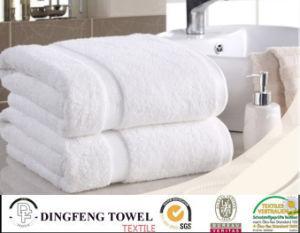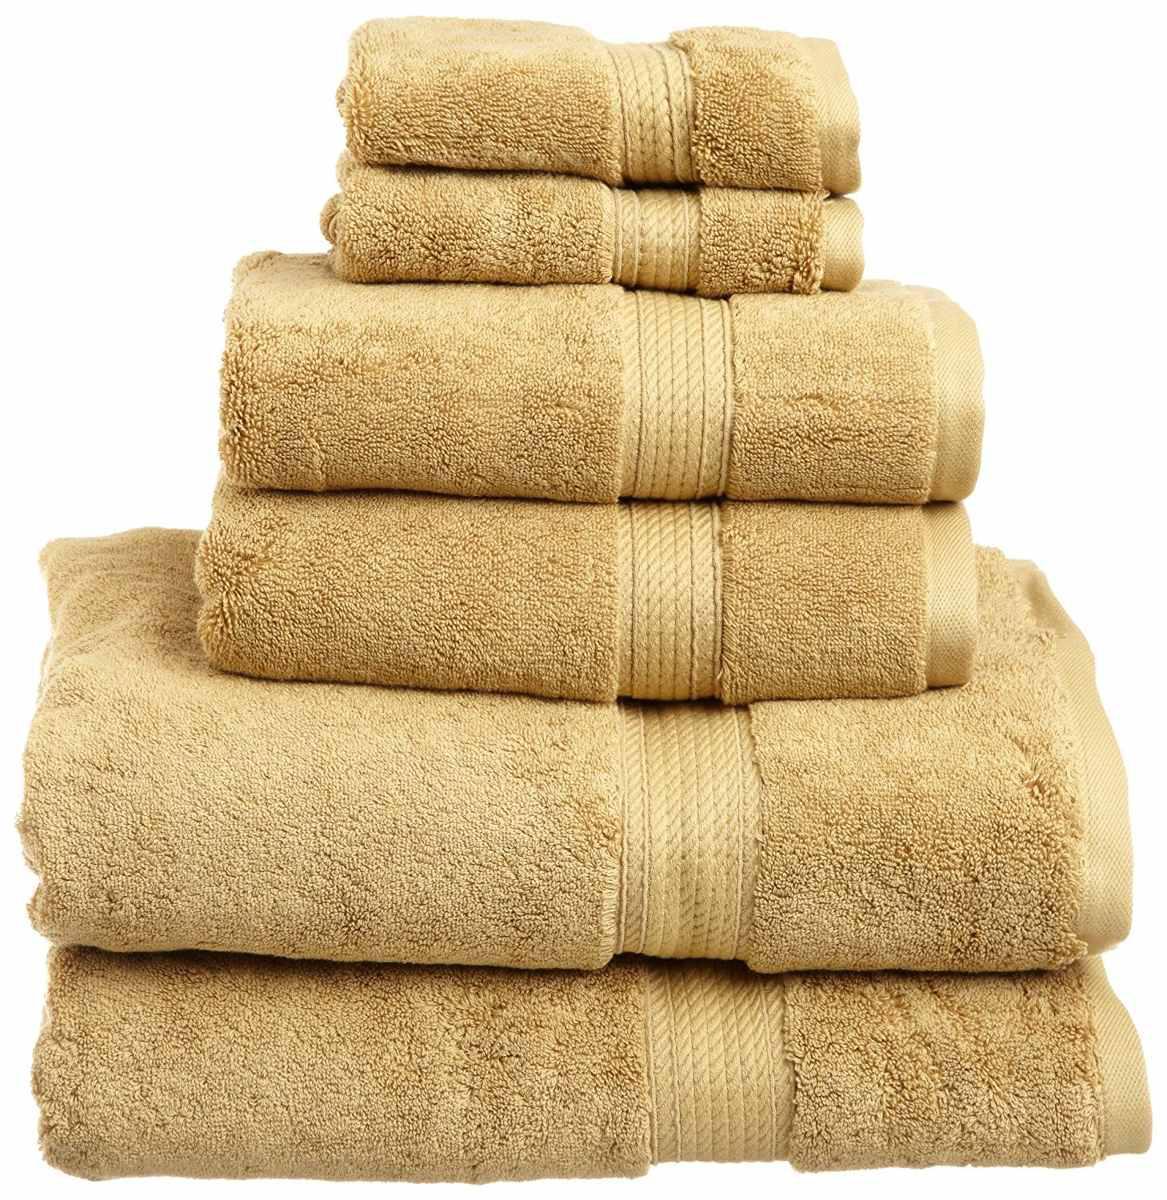The first image is the image on the left, the second image is the image on the right. Given the left and right images, does the statement "IN at least one image there is a tower of six folded towels." hold true? Answer yes or no. Yes. The first image is the image on the left, the second image is the image on the right. Assess this claim about the two images: "In one image, six towels the same color are folded and stacked according to size, smallest on top.". Correct or not? Answer yes or no. Yes. 